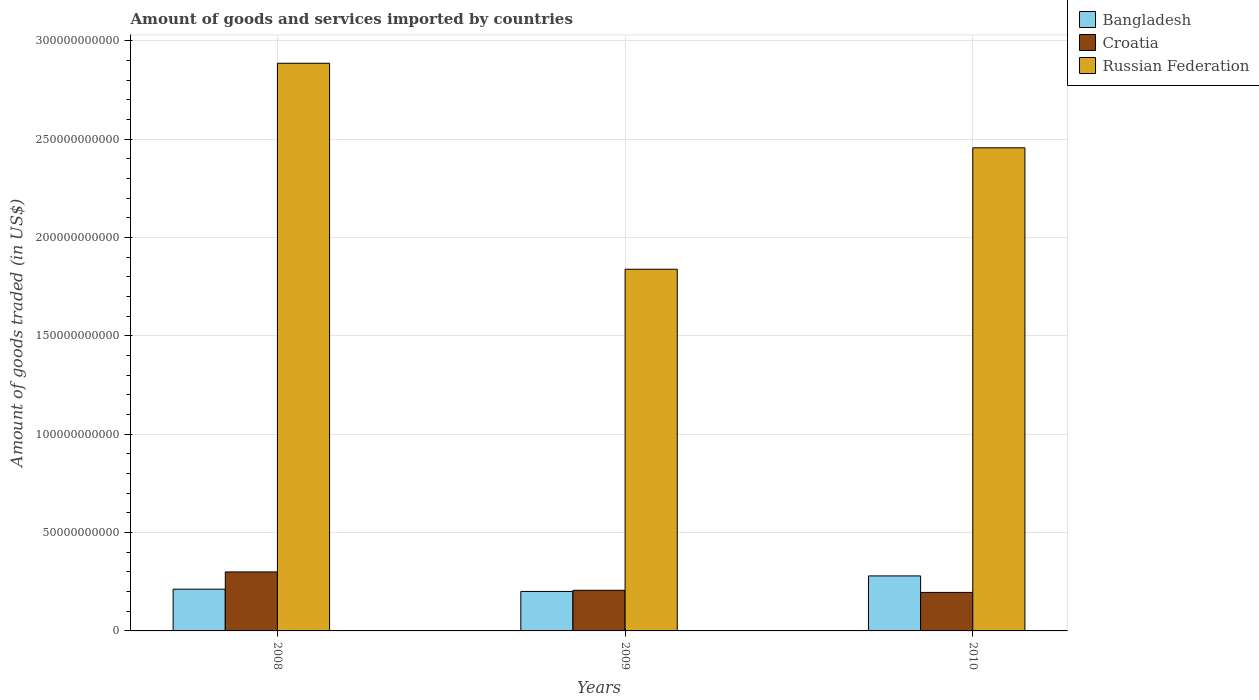Are the number of bars per tick equal to the number of legend labels?
Provide a short and direct response. Yes. In how many cases, is the number of bars for a given year not equal to the number of legend labels?
Make the answer very short. 0. What is the total amount of goods and services imported in Croatia in 2010?
Offer a terse response. 1.96e+1. Across all years, what is the maximum total amount of goods and services imported in Russian Federation?
Ensure brevity in your answer.  2.89e+11. Across all years, what is the minimum total amount of goods and services imported in Russian Federation?
Make the answer very short. 1.84e+11. In which year was the total amount of goods and services imported in Russian Federation maximum?
Your response must be concise. 2008. What is the total total amount of goods and services imported in Russian Federation in the graph?
Offer a terse response. 7.18e+11. What is the difference between the total amount of goods and services imported in Bangladesh in 2008 and that in 2010?
Your response must be concise. -6.74e+09. What is the difference between the total amount of goods and services imported in Bangladesh in 2008 and the total amount of goods and services imported in Croatia in 2009?
Offer a terse response. 5.63e+08. What is the average total amount of goods and services imported in Bangladesh per year?
Your answer should be very brief. 2.31e+1. In the year 2009, what is the difference between the total amount of goods and services imported in Russian Federation and total amount of goods and services imported in Croatia?
Provide a succinct answer. 1.63e+11. What is the ratio of the total amount of goods and services imported in Bangladesh in 2008 to that in 2010?
Your response must be concise. 0.76. What is the difference between the highest and the second highest total amount of goods and services imported in Bangladesh?
Offer a terse response. 6.74e+09. What is the difference between the highest and the lowest total amount of goods and services imported in Russian Federation?
Ensure brevity in your answer.  1.05e+11. Is the sum of the total amount of goods and services imported in Russian Federation in 2009 and 2010 greater than the maximum total amount of goods and services imported in Bangladesh across all years?
Ensure brevity in your answer.  Yes. What does the 2nd bar from the right in 2008 represents?
Your answer should be compact. Croatia. Is it the case that in every year, the sum of the total amount of goods and services imported in Russian Federation and total amount of goods and services imported in Croatia is greater than the total amount of goods and services imported in Bangladesh?
Give a very brief answer. Yes. How many years are there in the graph?
Your answer should be compact. 3. What is the difference between two consecutive major ticks on the Y-axis?
Provide a succinct answer. 5.00e+1. Are the values on the major ticks of Y-axis written in scientific E-notation?
Your response must be concise. No. Where does the legend appear in the graph?
Keep it short and to the point. Top right. How many legend labels are there?
Your answer should be very brief. 3. What is the title of the graph?
Offer a terse response. Amount of goods and services imported by countries. Does "Poland" appear as one of the legend labels in the graph?
Offer a terse response. No. What is the label or title of the Y-axis?
Your answer should be compact. Amount of goods traded (in US$). What is the Amount of goods traded (in US$) in Bangladesh in 2008?
Provide a succinct answer. 2.12e+1. What is the Amount of goods traded (in US$) in Croatia in 2008?
Offer a very short reply. 3.00e+1. What is the Amount of goods traded (in US$) of Russian Federation in 2008?
Your answer should be very brief. 2.89e+11. What is the Amount of goods traded (in US$) of Bangladesh in 2009?
Your answer should be compact. 2.01e+1. What is the Amount of goods traded (in US$) of Croatia in 2009?
Your answer should be very brief. 2.07e+1. What is the Amount of goods traded (in US$) in Russian Federation in 2009?
Give a very brief answer. 1.84e+11. What is the Amount of goods traded (in US$) in Bangladesh in 2010?
Your answer should be very brief. 2.80e+1. What is the Amount of goods traded (in US$) in Croatia in 2010?
Your answer should be very brief. 1.96e+1. What is the Amount of goods traded (in US$) of Russian Federation in 2010?
Keep it short and to the point. 2.46e+11. Across all years, what is the maximum Amount of goods traded (in US$) in Bangladesh?
Keep it short and to the point. 2.80e+1. Across all years, what is the maximum Amount of goods traded (in US$) of Croatia?
Offer a terse response. 3.00e+1. Across all years, what is the maximum Amount of goods traded (in US$) in Russian Federation?
Keep it short and to the point. 2.89e+11. Across all years, what is the minimum Amount of goods traded (in US$) of Bangladesh?
Ensure brevity in your answer.  2.01e+1. Across all years, what is the minimum Amount of goods traded (in US$) of Croatia?
Make the answer very short. 1.96e+1. Across all years, what is the minimum Amount of goods traded (in US$) in Russian Federation?
Provide a short and direct response. 1.84e+11. What is the total Amount of goods traded (in US$) of Bangladesh in the graph?
Provide a succinct answer. 6.93e+1. What is the total Amount of goods traded (in US$) of Croatia in the graph?
Provide a short and direct response. 7.03e+1. What is the total Amount of goods traded (in US$) of Russian Federation in the graph?
Provide a short and direct response. 7.18e+11. What is the difference between the Amount of goods traded (in US$) of Bangladesh in 2008 and that in 2009?
Provide a succinct answer. 1.15e+09. What is the difference between the Amount of goods traded (in US$) in Croatia in 2008 and that in 2009?
Give a very brief answer. 9.34e+09. What is the difference between the Amount of goods traded (in US$) in Russian Federation in 2008 and that in 2009?
Offer a terse response. 1.05e+11. What is the difference between the Amount of goods traded (in US$) in Bangladesh in 2008 and that in 2010?
Your response must be concise. -6.74e+09. What is the difference between the Amount of goods traded (in US$) in Croatia in 2008 and that in 2010?
Provide a succinct answer. 1.04e+1. What is the difference between the Amount of goods traded (in US$) in Russian Federation in 2008 and that in 2010?
Give a very brief answer. 4.30e+1. What is the difference between the Amount of goods traded (in US$) of Bangladesh in 2009 and that in 2010?
Offer a terse response. -7.89e+09. What is the difference between the Amount of goods traded (in US$) of Croatia in 2009 and that in 2010?
Provide a short and direct response. 1.08e+09. What is the difference between the Amount of goods traded (in US$) of Russian Federation in 2009 and that in 2010?
Make the answer very short. -6.18e+1. What is the difference between the Amount of goods traded (in US$) in Bangladesh in 2008 and the Amount of goods traded (in US$) in Croatia in 2009?
Your response must be concise. 5.63e+08. What is the difference between the Amount of goods traded (in US$) of Bangladesh in 2008 and the Amount of goods traded (in US$) of Russian Federation in 2009?
Ensure brevity in your answer.  -1.63e+11. What is the difference between the Amount of goods traded (in US$) in Croatia in 2008 and the Amount of goods traded (in US$) in Russian Federation in 2009?
Give a very brief answer. -1.54e+11. What is the difference between the Amount of goods traded (in US$) in Bangladesh in 2008 and the Amount of goods traded (in US$) in Croatia in 2010?
Provide a succinct answer. 1.64e+09. What is the difference between the Amount of goods traded (in US$) in Bangladesh in 2008 and the Amount of goods traded (in US$) in Russian Federation in 2010?
Ensure brevity in your answer.  -2.24e+11. What is the difference between the Amount of goods traded (in US$) of Croatia in 2008 and the Amount of goods traded (in US$) of Russian Federation in 2010?
Provide a succinct answer. -2.16e+11. What is the difference between the Amount of goods traded (in US$) in Bangladesh in 2009 and the Amount of goods traded (in US$) in Croatia in 2010?
Your answer should be compact. 4.94e+08. What is the difference between the Amount of goods traded (in US$) of Bangladesh in 2009 and the Amount of goods traded (in US$) of Russian Federation in 2010?
Your answer should be compact. -2.26e+11. What is the difference between the Amount of goods traded (in US$) of Croatia in 2009 and the Amount of goods traded (in US$) of Russian Federation in 2010?
Your response must be concise. -2.25e+11. What is the average Amount of goods traded (in US$) of Bangladesh per year?
Make the answer very short. 2.31e+1. What is the average Amount of goods traded (in US$) of Croatia per year?
Offer a very short reply. 2.34e+1. What is the average Amount of goods traded (in US$) in Russian Federation per year?
Your response must be concise. 2.39e+11. In the year 2008, what is the difference between the Amount of goods traded (in US$) in Bangladesh and Amount of goods traded (in US$) in Croatia?
Give a very brief answer. -8.77e+09. In the year 2008, what is the difference between the Amount of goods traded (in US$) in Bangladesh and Amount of goods traded (in US$) in Russian Federation?
Provide a short and direct response. -2.67e+11. In the year 2008, what is the difference between the Amount of goods traded (in US$) of Croatia and Amount of goods traded (in US$) of Russian Federation?
Your response must be concise. -2.59e+11. In the year 2009, what is the difference between the Amount of goods traded (in US$) in Bangladesh and Amount of goods traded (in US$) in Croatia?
Your answer should be compact. -5.88e+08. In the year 2009, what is the difference between the Amount of goods traded (in US$) in Bangladesh and Amount of goods traded (in US$) in Russian Federation?
Keep it short and to the point. -1.64e+11. In the year 2009, what is the difference between the Amount of goods traded (in US$) of Croatia and Amount of goods traded (in US$) of Russian Federation?
Your response must be concise. -1.63e+11. In the year 2010, what is the difference between the Amount of goods traded (in US$) in Bangladesh and Amount of goods traded (in US$) in Croatia?
Your answer should be very brief. 8.39e+09. In the year 2010, what is the difference between the Amount of goods traded (in US$) in Bangladesh and Amount of goods traded (in US$) in Russian Federation?
Give a very brief answer. -2.18e+11. In the year 2010, what is the difference between the Amount of goods traded (in US$) in Croatia and Amount of goods traded (in US$) in Russian Federation?
Keep it short and to the point. -2.26e+11. What is the ratio of the Amount of goods traded (in US$) in Bangladesh in 2008 to that in 2009?
Provide a short and direct response. 1.06. What is the ratio of the Amount of goods traded (in US$) of Croatia in 2008 to that in 2009?
Give a very brief answer. 1.45. What is the ratio of the Amount of goods traded (in US$) in Russian Federation in 2008 to that in 2009?
Offer a very short reply. 1.57. What is the ratio of the Amount of goods traded (in US$) in Bangladesh in 2008 to that in 2010?
Your answer should be very brief. 0.76. What is the ratio of the Amount of goods traded (in US$) of Croatia in 2008 to that in 2010?
Your answer should be compact. 1.53. What is the ratio of the Amount of goods traded (in US$) in Russian Federation in 2008 to that in 2010?
Offer a very short reply. 1.18. What is the ratio of the Amount of goods traded (in US$) of Bangladesh in 2009 to that in 2010?
Your answer should be compact. 0.72. What is the ratio of the Amount of goods traded (in US$) in Croatia in 2009 to that in 2010?
Ensure brevity in your answer.  1.06. What is the ratio of the Amount of goods traded (in US$) of Russian Federation in 2009 to that in 2010?
Make the answer very short. 0.75. What is the difference between the highest and the second highest Amount of goods traded (in US$) of Bangladesh?
Provide a short and direct response. 6.74e+09. What is the difference between the highest and the second highest Amount of goods traded (in US$) of Croatia?
Provide a short and direct response. 9.34e+09. What is the difference between the highest and the second highest Amount of goods traded (in US$) in Russian Federation?
Offer a very short reply. 4.30e+1. What is the difference between the highest and the lowest Amount of goods traded (in US$) in Bangladesh?
Make the answer very short. 7.89e+09. What is the difference between the highest and the lowest Amount of goods traded (in US$) in Croatia?
Give a very brief answer. 1.04e+1. What is the difference between the highest and the lowest Amount of goods traded (in US$) of Russian Federation?
Your response must be concise. 1.05e+11. 